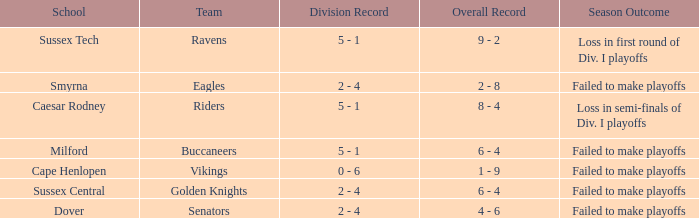Would you mind parsing the complete table? {'header': ['School', 'Team', 'Division Record', 'Overall Record', 'Season Outcome'], 'rows': [['Sussex Tech', 'Ravens', '5 - 1', '9 - 2', 'Loss in first round of Div. I playoffs'], ['Smyrna', 'Eagles', '2 - 4', '2 - 8', 'Failed to make playoffs'], ['Caesar Rodney', 'Riders', '5 - 1', '8 - 4', 'Loss in semi-finals of Div. I playoffs'], ['Milford', 'Buccaneers', '5 - 1', '6 - 4', 'Failed to make playoffs'], ['Cape Henlopen', 'Vikings', '0 - 6', '1 - 9', 'Failed to make playoffs'], ['Sussex Central', 'Golden Knights', '2 - 4', '6 - 4', 'Failed to make playoffs'], ['Dover', 'Senators', '2 - 4', '4 - 6', 'Failed to make playoffs']]} What is the Overall Record for the School in Milford? 6 - 4. 